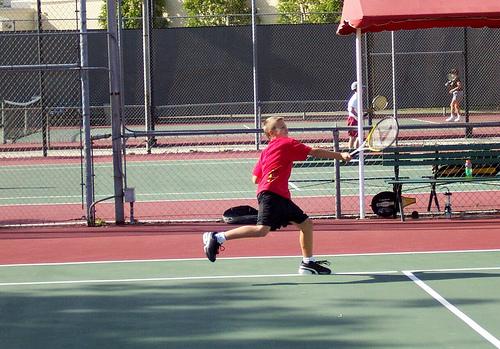Does the man in the foreground have his left foot on the ground?
Concise answer only. Yes. What color is the man's shirt?
Short answer required. Red. What kind of shoes is the man wearing?
Quick response, please. Sneakers. 